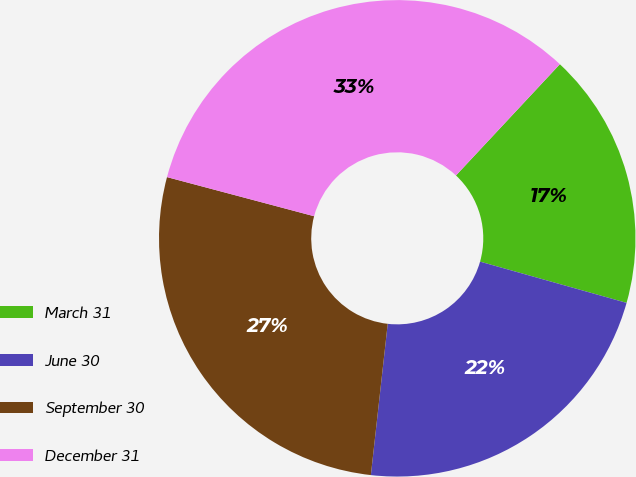Convert chart. <chart><loc_0><loc_0><loc_500><loc_500><pie_chart><fcel>March 31<fcel>June 30<fcel>September 30<fcel>December 31<nl><fcel>17.41%<fcel>22.4%<fcel>27.37%<fcel>32.82%<nl></chart> 